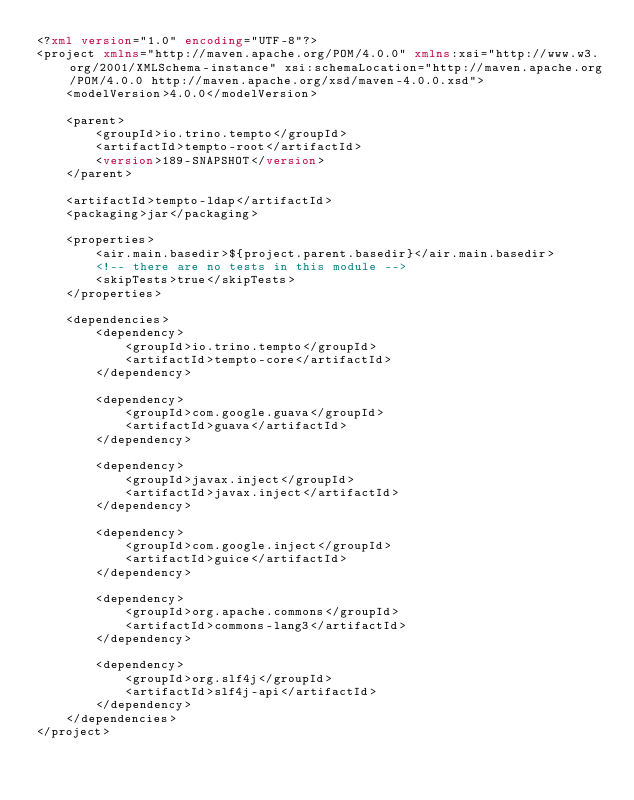<code> <loc_0><loc_0><loc_500><loc_500><_XML_><?xml version="1.0" encoding="UTF-8"?>
<project xmlns="http://maven.apache.org/POM/4.0.0" xmlns:xsi="http://www.w3.org/2001/XMLSchema-instance" xsi:schemaLocation="http://maven.apache.org/POM/4.0.0 http://maven.apache.org/xsd/maven-4.0.0.xsd">
    <modelVersion>4.0.0</modelVersion>

    <parent>
        <groupId>io.trino.tempto</groupId>
        <artifactId>tempto-root</artifactId>
        <version>189-SNAPSHOT</version>
    </parent>

    <artifactId>tempto-ldap</artifactId>
    <packaging>jar</packaging>

    <properties>
        <air.main.basedir>${project.parent.basedir}</air.main.basedir>
        <!-- there are no tests in this module -->
        <skipTests>true</skipTests>
    </properties>

    <dependencies>
        <dependency>
            <groupId>io.trino.tempto</groupId>
            <artifactId>tempto-core</artifactId>
        </dependency>

        <dependency>
            <groupId>com.google.guava</groupId>
            <artifactId>guava</artifactId>
        </dependency>

        <dependency>
            <groupId>javax.inject</groupId>
            <artifactId>javax.inject</artifactId>
        </dependency>

        <dependency>
            <groupId>com.google.inject</groupId>
            <artifactId>guice</artifactId>
        </dependency>

        <dependency>
            <groupId>org.apache.commons</groupId>
            <artifactId>commons-lang3</artifactId>
        </dependency>

        <dependency>
            <groupId>org.slf4j</groupId>
            <artifactId>slf4j-api</artifactId>
        </dependency>
    </dependencies>
</project>
</code> 